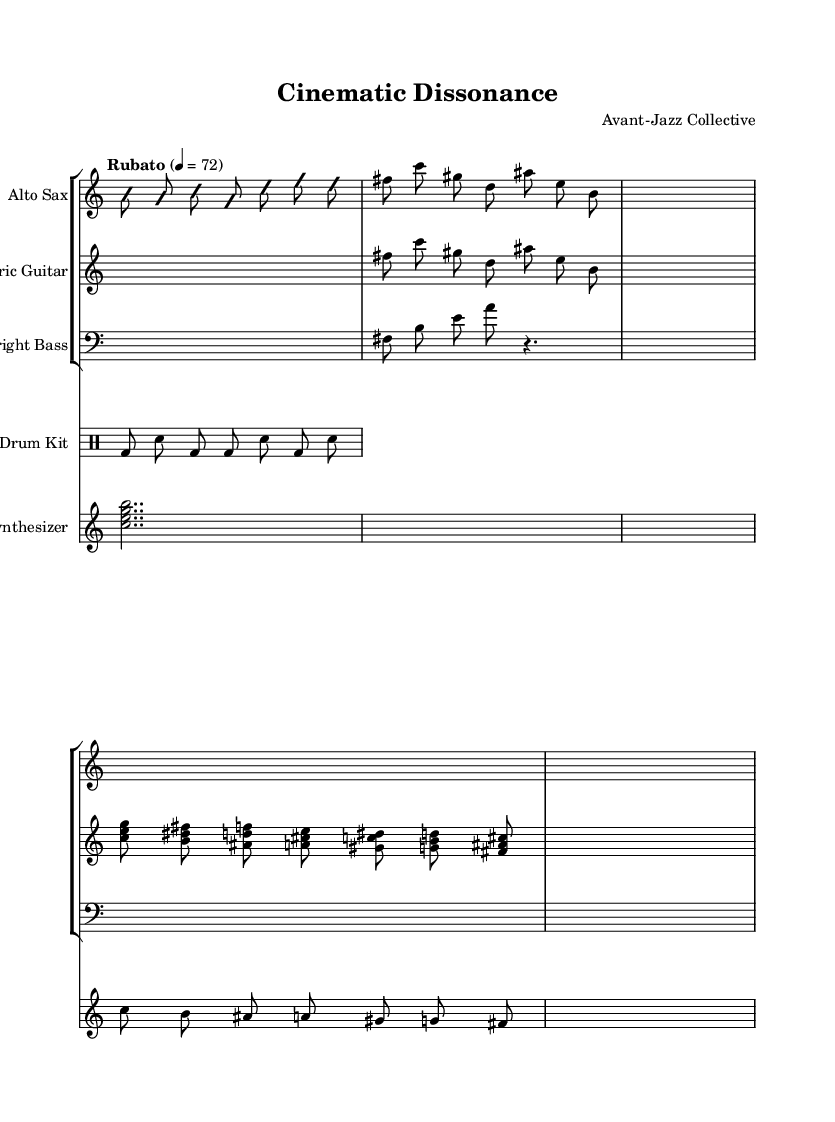What is the time signature of this music? The time signature is indicated by the notation at the beginning of the score, which shows a "7/8" time signature. This means there are seven eighth notes in each measure.
Answer: 7/8 What is the tempo marking for this piece? The tempo is provided right after the time signature, indicated as "Rubato" with a metronome marking of "4 = 72," suggesting a flexible tempo around 72 beats per minute.
Answer: Rubato How many instruments are featured in the composition? By looking at the score, there are five different parts: Alto Sax, Electric Guitar, Upright Bass, Drum Kit, and Synthesizer, which indicates the number of instruments.
Answer: Five What does "improvisationOn" signify in the music? "improvisationOn" indicates sections where the musician is encouraged to create spontaneous music instead of following a notated part. This is common in jazz to showcase creativity.
Answer: Spontaneity Which section utilizes a drum pattern? The section labeled "drumKit" is specifically for the drum pattern, where the notation indicates the beat and rhythm played by the drums.
Answer: Drum Kit Identify a theme present in the music. The piece clearly outlines Theme A and Theme B within the sections labeled as such, demonstrating distinct melodic ideas intended for repetition or variation throughout the composition.
Answer: Theme A and Theme B What scale is predominantly used in the Alto Sax part? The notes of the Alto Sax part primarily feature a mix of both minor and major elements, particularly emphasizing the natural minor scale, as noted by the pitches presented.
Answer: Natural minor scale 